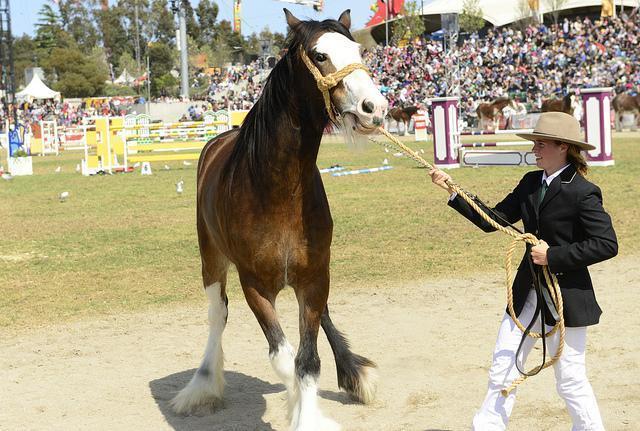How many horses can you see?
Give a very brief answer. 1. How many people are visible?
Give a very brief answer. 2. 